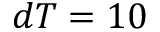Convert formula to latex. <formula><loc_0><loc_0><loc_500><loc_500>d T = 1 0</formula> 